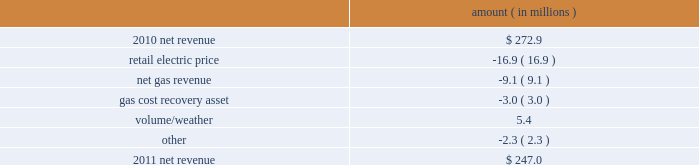Entergy new orleans , inc .
Management 2019s financial discussion and analysis plan to spin off the utility 2019s transmission business see the 201cplan to spin off the utility 2019s transmission business 201d section of entergy corporation and subsidiaries management 2019s financial discussion and analysis for a discussion of this matter , including the planned retirement of debt and preferred securities .
Results of operations net income 2011 compared to 2010 net income increased $ 4.9 million primarily due to lower other operation and maintenance expenses , lower taxes other than income taxes , a lower effective income tax rate , and lower interest expense , partially offset by lower net revenue .
2010 compared to 2009 net income remained relatively unchanged , increasing $ 0.6 million , primarily due to higher net revenue and lower interest expense , almost entirely offset by higher other operation and maintenance expenses , higher taxes other than income taxes , lower other income , and higher depreciation and amortization expenses .
Net revenue 2011 compared to 2010 net revenue consists of operating revenues net of : 1 ) fuel , fuel-related expenses , and gas purchased for resale , 2 ) purchased power expenses , and 3 ) other regulatory charges ( credits ) .
Following is an analysis of the change in net revenue comparing 2011 to 2010 .
Amount ( in millions ) .
The retail electric price variance is primarily due to formula rate plan decreases effective october 2010 and october 2011 .
See note 2 to the financial statements for a discussion of the formula rate plan filing .
The net gas revenue variance is primarily due to milder weather in 2011 compared to 2010 .
The gas cost recovery asset variance is primarily due to the recognition in 2010 of a $ 3 million gas operations regulatory asset associated with the settlement of entergy new orleans 2019s electric and gas formula rate plan case and the amortization of that asset .
See note 2 to the financial statements for additional discussion of the formula rate plan settlement. .
What was the average net revenue between 2010 and 2011? 
Computations: (((272.9 + 247.0) + 2) / 2)
Answer: 260.95. 